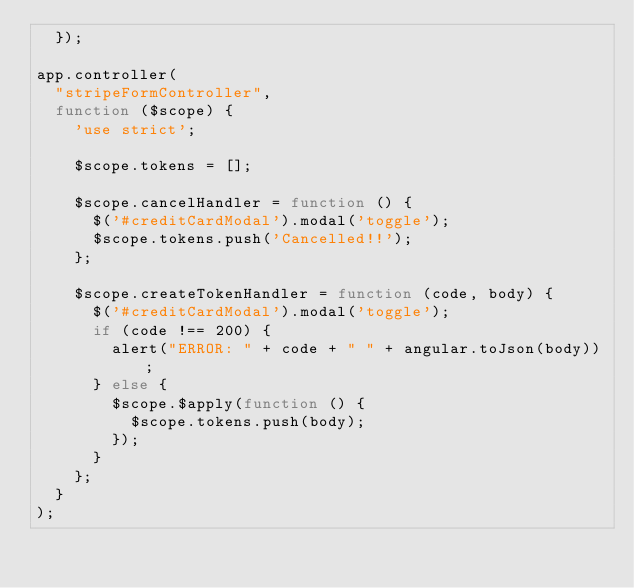<code> <loc_0><loc_0><loc_500><loc_500><_JavaScript_>  });

app.controller(
  "stripeFormController",
  function ($scope) {
    'use strict';

    $scope.tokens = [];

    $scope.cancelHandler = function () {
      $('#creditCardModal').modal('toggle');
      $scope.tokens.push('Cancelled!!');
    };

    $scope.createTokenHandler = function (code, body) {
      $('#creditCardModal').modal('toggle');
      if (code !== 200) {
        alert("ERROR: " + code + " " + angular.toJson(body));
      } else {
        $scope.$apply(function () {
          $scope.tokens.push(body);
        });
      }
    };
  }
);</code> 